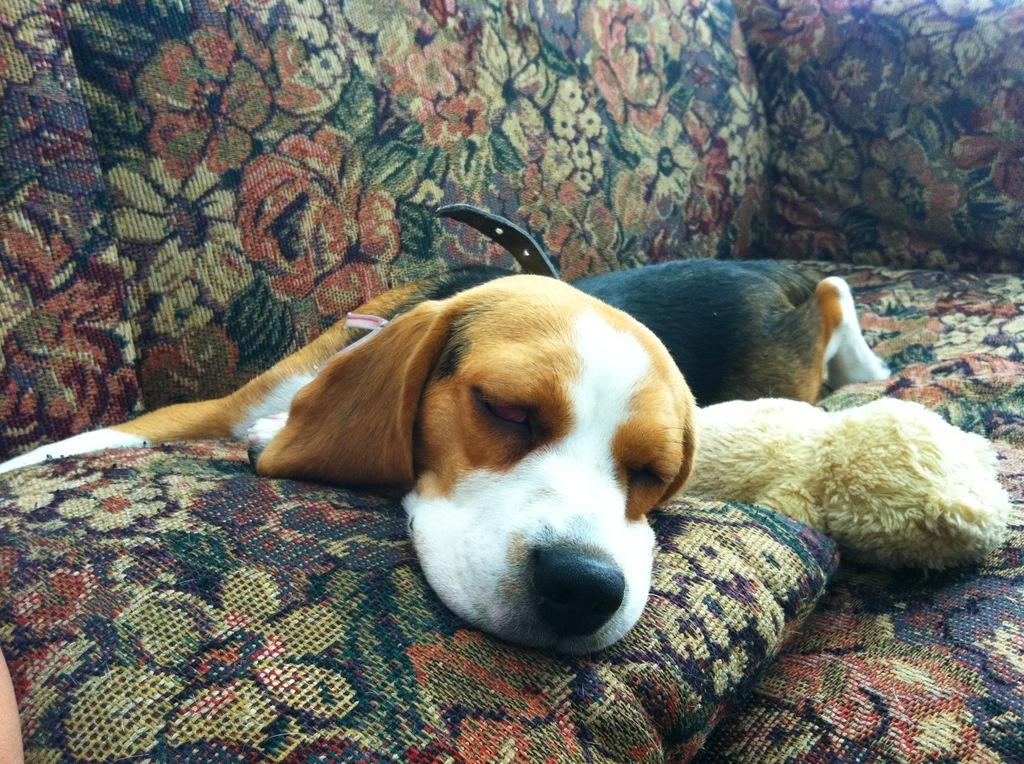What object can be seen in the image that is typically used for play? There is a toy in the image. What object can be seen in the image that is typically used for comfort? There is a pillow in the image. What type of animal is present in the image? There is a dog in the image. What is the dog wearing in the image? The dog is wearing a belt in the image. Where is the dog located in the image? The dog is sleeping on a sofa in the image. What type of fog can be seen surrounding the dog in the image? There is no fog present in the image; the dog is sleeping on a sofa. What type of dinosaur is visible in the image? There are no dinosaurs present in the image; the main subjects are a toy, a pillow, and a dog. 